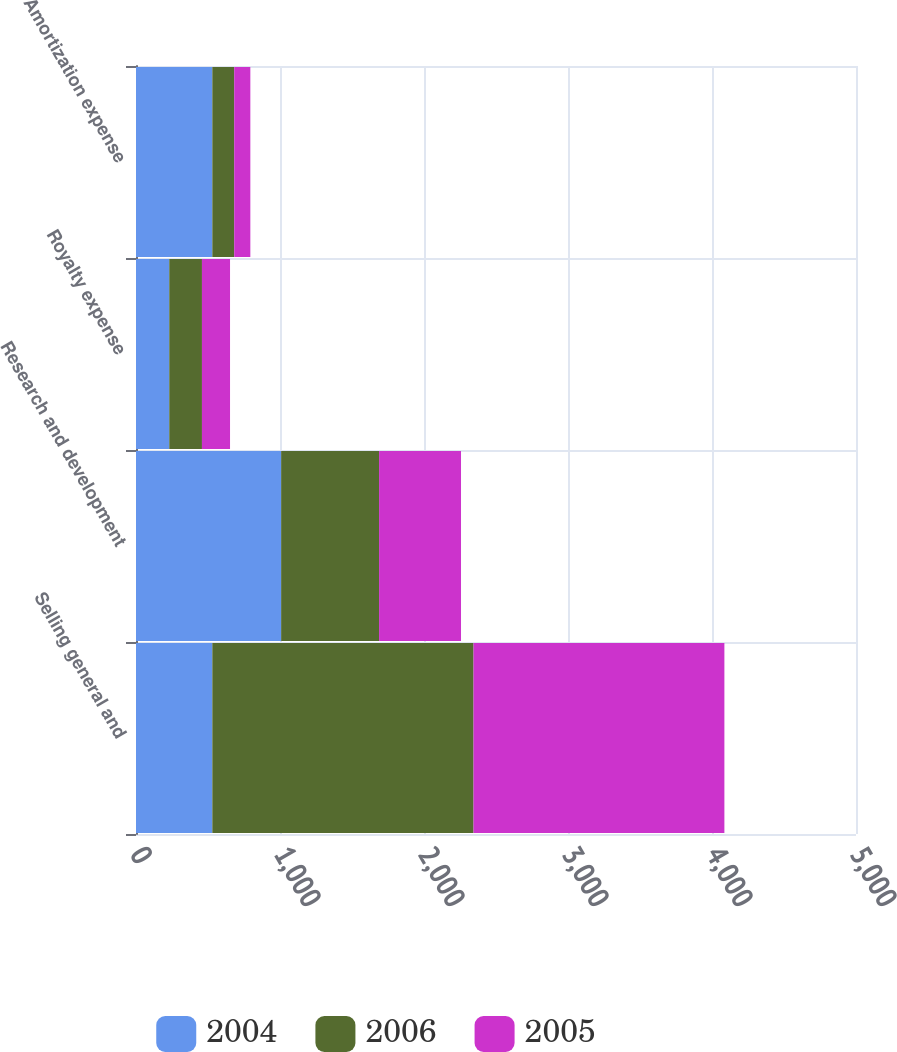<chart> <loc_0><loc_0><loc_500><loc_500><stacked_bar_chart><ecel><fcel>Selling general and<fcel>Research and development<fcel>Royalty expense<fcel>Amortization expense<nl><fcel>2004<fcel>530<fcel>1008<fcel>231<fcel>530<nl><fcel>2006<fcel>1814<fcel>680<fcel>227<fcel>152<nl><fcel>2005<fcel>1742<fcel>569<fcel>195<fcel>112<nl></chart> 